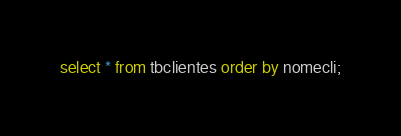<code> <loc_0><loc_0><loc_500><loc_500><_SQL_>select * from tbclientes order by nomecli;</code> 